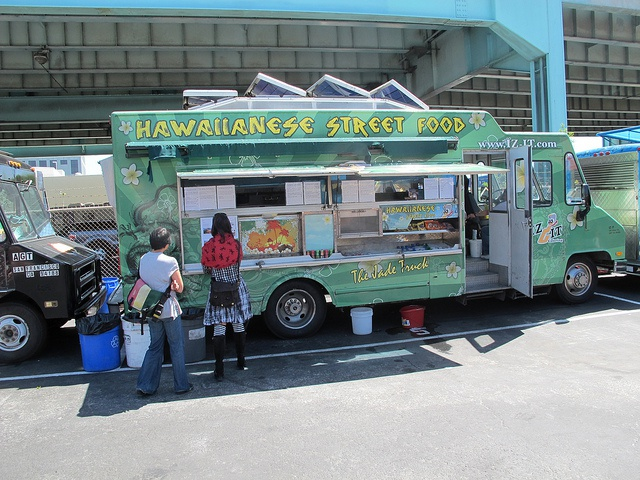Describe the objects in this image and their specific colors. I can see truck in lightblue, gray, teal, darkgray, and black tones, truck in lightblue, black, darkgray, and gray tones, people in lightblue, navy, black, blue, and darkgray tones, people in lightblue, black, gray, and brown tones, and car in lightblue, black, gray, and darkgray tones in this image. 